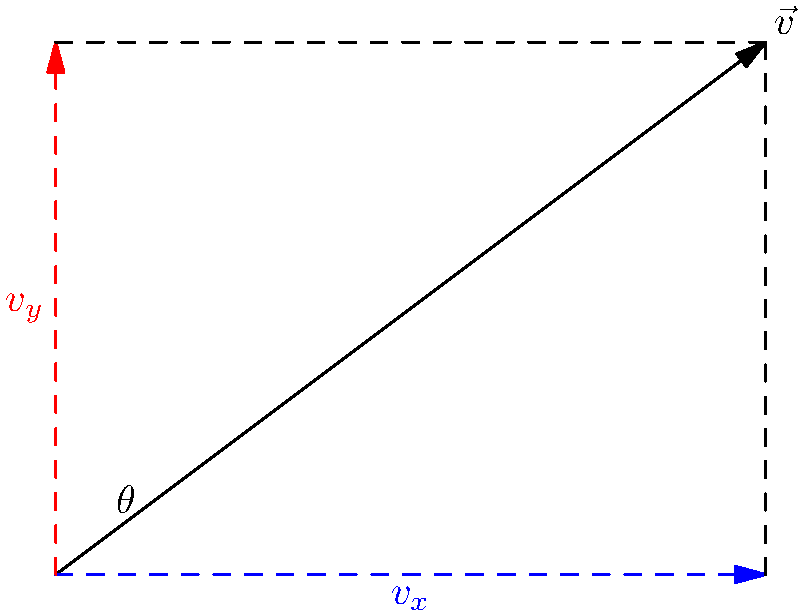In the context of applying cognitive load theory to teach vector decomposition, explain how you would use this diagram to help students understand the relationship between a vector's magnitude, its components, and the angle it makes with the x-axis. How does this visual representation potentially reduce cognitive load for students? To explain vector decomposition using cognitive load theory and this diagram:

1. Start with the main vector $\vec{v}$, emphasizing its magnitude and direction.

2. Introduce the concept of components:
   a) $v_x$ (blue) is the horizontal component
   b) $v_y$ (red) is the vertical component

3. Explain the right triangle formed by $\vec{v}$, $v_x$, and $v_y$.

4. Use the Pythagorean theorem to relate magnitudes:
   $$|\vec{v}|^2 = v_x^2 + v_y^2$$

5. Introduce trigonometric relationships:
   $$\cos\theta = \frac{v_x}{|\vec{v}|}$$
   $$\sin\theta = \frac{v_y}{|\vec{v}|}$$

6. Show how to calculate components:
   $$v_x = |\vec{v}| \cos\theta$$
   $$v_y = |\vec{v}| \sin\theta$$

This visual representation reduces cognitive load by:
- Chunking information: The diagram groups related concepts (vector, components, angle) visually.
- Using dual coding: Combining visual and verbal information enhances understanding.
- Providing a schema: The right triangle serves as a familiar framework for new information.
- Eliminating extraneous information: Only essential elements are included, reducing distractions.

By presenting this information visually and step-by-step, students can focus on understanding one concept at a time, reducing the overall cognitive load and facilitating deeper learning.
Answer: Visual representation reduces cognitive load by chunking information, using dual coding, providing a schema, and eliminating extraneous details. 